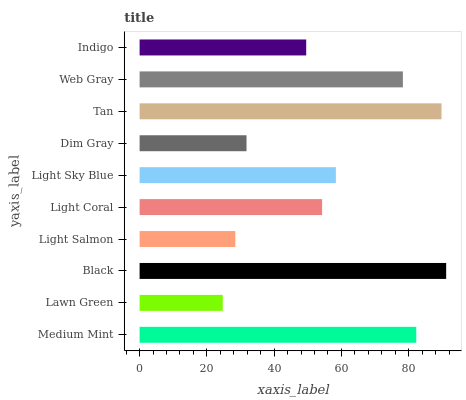Is Lawn Green the minimum?
Answer yes or no. Yes. Is Black the maximum?
Answer yes or no. Yes. Is Black the minimum?
Answer yes or no. No. Is Lawn Green the maximum?
Answer yes or no. No. Is Black greater than Lawn Green?
Answer yes or no. Yes. Is Lawn Green less than Black?
Answer yes or no. Yes. Is Lawn Green greater than Black?
Answer yes or no. No. Is Black less than Lawn Green?
Answer yes or no. No. Is Light Sky Blue the high median?
Answer yes or no. Yes. Is Light Coral the low median?
Answer yes or no. Yes. Is Medium Mint the high median?
Answer yes or no. No. Is Medium Mint the low median?
Answer yes or no. No. 